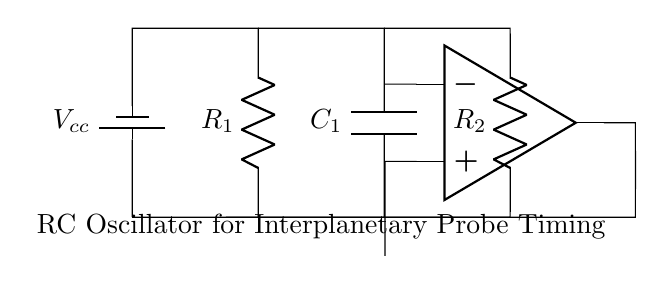What components are present in this circuit? The components visible in the circuit include two resistors (R1 and R2), one capacitor (C1), and an operational amplifier. These components are identified by their symbols in the diagram.
Answer: Resistors, capacitor, operational amplifier What is the function of the capacitor in this RC oscillator? The capacitor (C1) in the RC oscillator is responsible for charging and discharging, which creates the timing mechanism needed for oscillation. Its charge-discharge cycles determine the frequency of oscillation.
Answer: Timing mechanism What is the voltage supply in this circuit? The circuit diagram indicates a battery connected with the label Vcc, which represents the voltage supply.
Answer: Vcc What type of oscillator is represented by this circuit? The circuit represents a relaxation oscillator type due to the presence of resistors and a capacitor, which are used to generate square wave signals.
Answer: Relaxation oscillator How does the timing period of the oscillator depend on the resistor and capacitor values? The timing period is determined by the values of the resistors (R1 and R2) and the capacitor (C1). The period is proportional to R * C, specifically (R1 + R2) * C for this arrangement. This relationship highlights how changes in these values directly impact the timing frequency.
Answer: R1, R2, C What occurs to the output of the operational amplifier in this circuit? The output of the operational amplifier oscillates between high and low states, creating a square wave output based on the charging and discharging cycles of the capacitor and the resistors involved. This output signal can be used for timing and control purposes in the probe.
Answer: Oscillates 